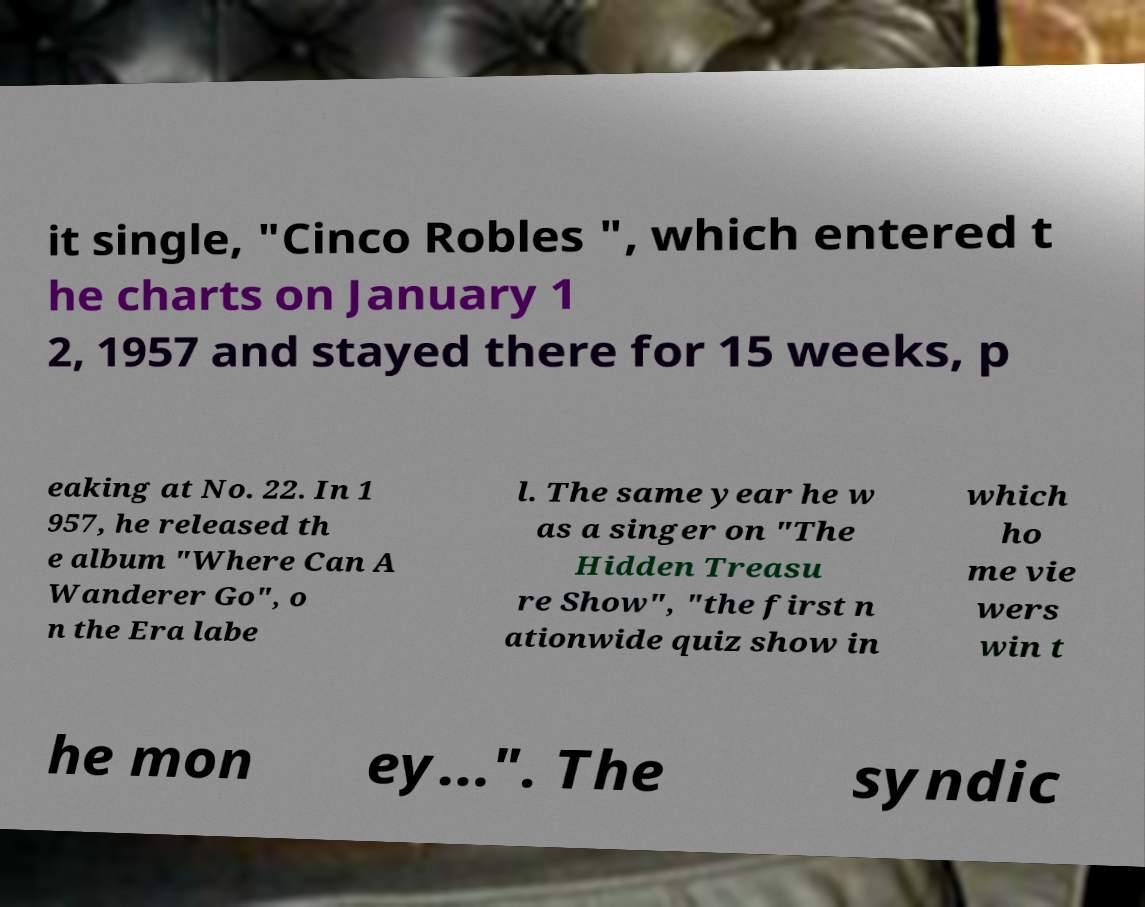There's text embedded in this image that I need extracted. Can you transcribe it verbatim? it single, "Cinco Robles ", which entered t he charts on January 1 2, 1957 and stayed there for 15 weeks, p eaking at No. 22. In 1 957, he released th e album "Where Can A Wanderer Go", o n the Era labe l. The same year he w as a singer on "The Hidden Treasu re Show", "the first n ationwide quiz show in which ho me vie wers win t he mon ey...". The syndic 